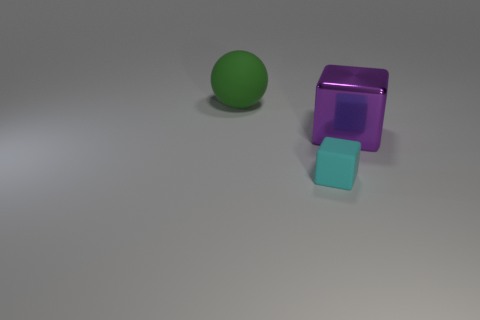Are there any other things that are the same size as the matte block?
Offer a very short reply. No. What is the shape of the object that is the same material as the cyan block?
Your answer should be very brief. Sphere. There is a green thing that is the same material as the cyan object; what is its size?
Provide a succinct answer. Large. There is a thing that is both in front of the big rubber thing and on the left side of the purple metal cube; what shape is it?
Give a very brief answer. Cube. There is a matte object right of the big thing that is behind the purple metallic block; how big is it?
Offer a very short reply. Small. What number of other things are the same color as the tiny rubber thing?
Offer a very short reply. 0. What is the big purple thing made of?
Make the answer very short. Metal. Is there a large brown cylinder?
Your answer should be very brief. No. Are there an equal number of small rubber cubes left of the tiny rubber block and tiny yellow rubber cylinders?
Your answer should be very brief. Yes. Is there any other thing that is the same material as the large purple block?
Ensure brevity in your answer.  No. 